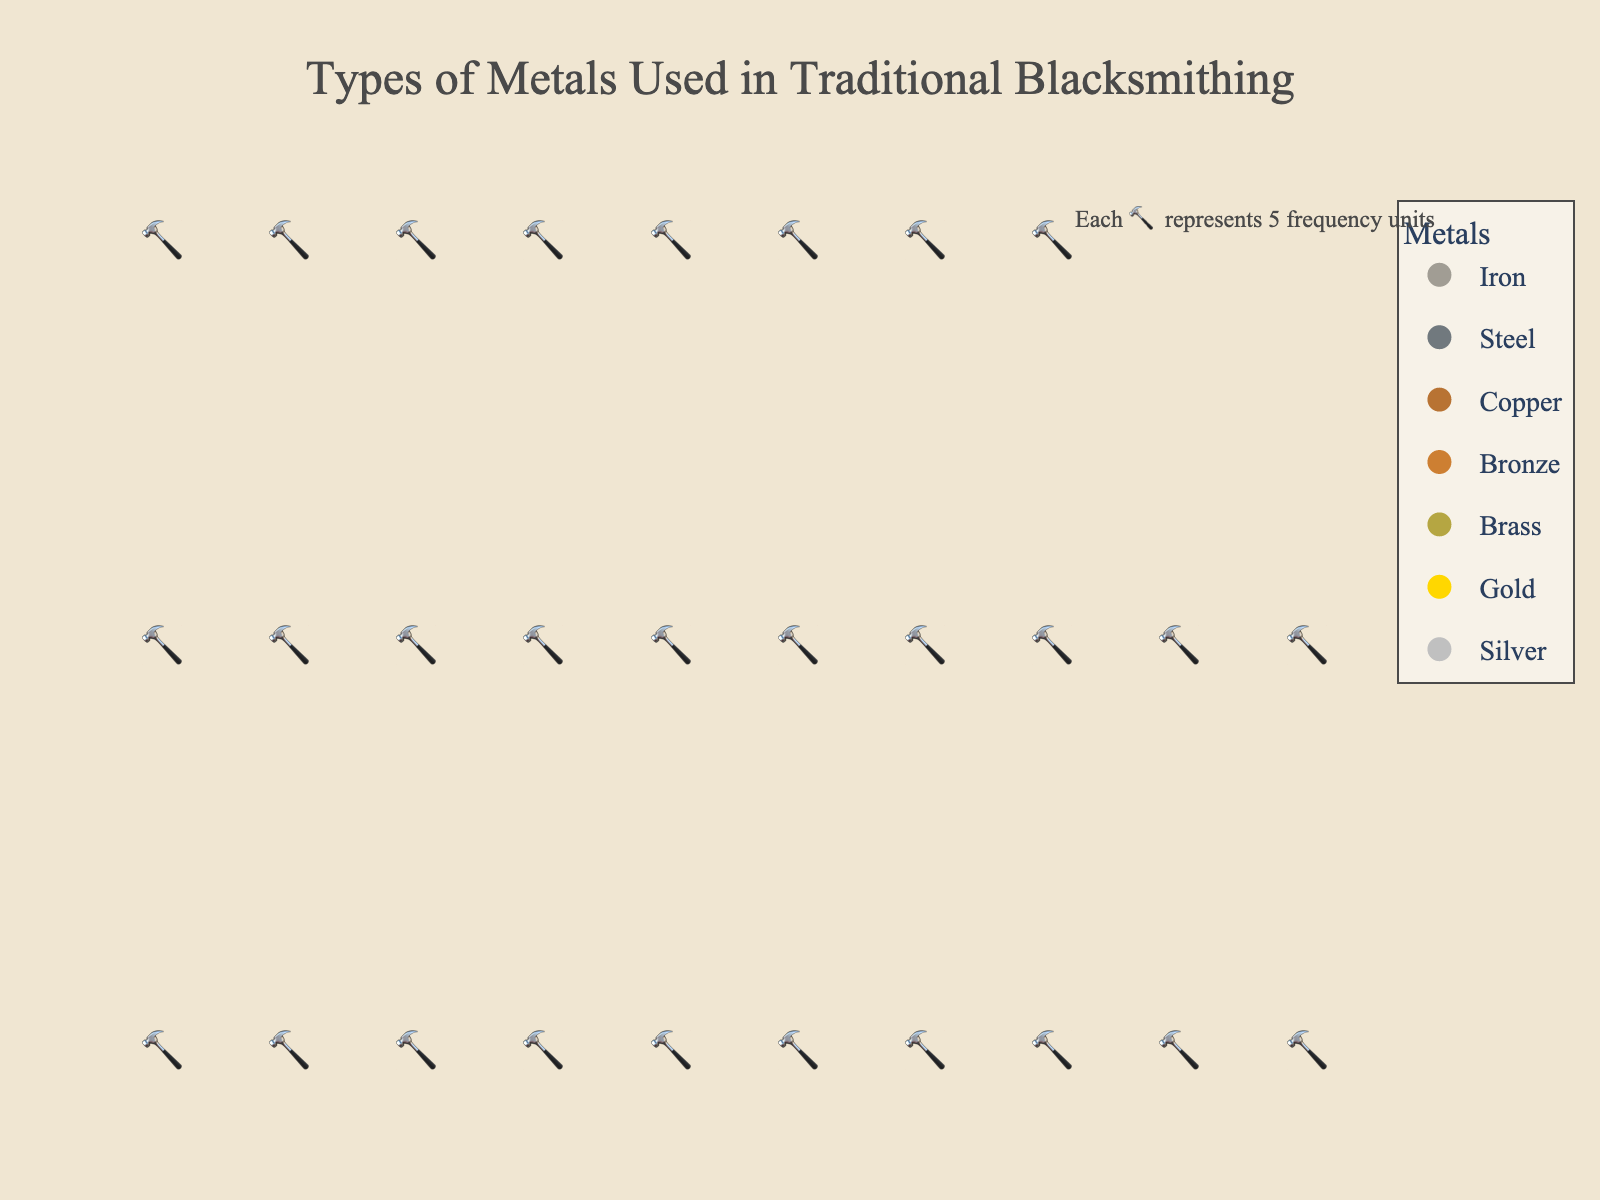What is the title of the plot? The title of the plot is written at the top and describes what the figure represents.
Answer: Types of Metals Used in Traditional Blacksmithing How many different types of metals are represented in the plot? Each unique symbol color and label in the legend correspond to different types of metals used. Counting them gives the answer.
Answer: 7 Which metal is used most frequently? The metal with the most 🔨 icons signifies the highest frequency. The one with the greatest number of icons is the most frequent.
Answer: Iron How many more times is Iron used compared to Silver? Count the 🔨 icons representing both metals. Iron has 50/5 = 10 icons, and Silver has 3/5 = 0 icons (each representing 5 units). Calculate the difference: 10 - 0.
Answer: 10 times What percentage of the total do Brass and Bronze combined account for? Determine the frequencies of both metals from the legend or icon count, sum them (Bronze = 15, Brass = 10), then divide by the total frequency for all metals (143), and multiply by 100 to get the percentage.
Answer: 17.48% How many metals have a frequency of use above 20? Identify metals from the plot with a visual count above 20 🔨. The metals Iron (50), Steel (40), and Copper (20) fit this criterion.
Answer: 2 Which metal has a frequency usage closest to Gold? Look at the frequencies of the metals and find the one nearest to Gold's frequency of 5. Brass has a frequency of 10, which is closest.
Answer: Brass What's the total combined frequency of Steel and Copper? Refer to the plot to find frequencies of Steel (40) and Copper (20). Sum them to find the total combined frequency.
Answer: 60 How many 🔨 icons represent the total frequency of Copper and Bronze? Calculate each metal's number of icons (Copper = 20/5 = 4, Bronze = 15/5 = 3). Sum these to find the total number of icons.
Answer: 7 icons Which metal is used less frequently, Silver or Gold? Compare the number of symbols or legend values for Silver and Gold. Silver has a frequency of 3, and Gold has a frequency of 5, making Silver the less frequent.
Answer: Silver 